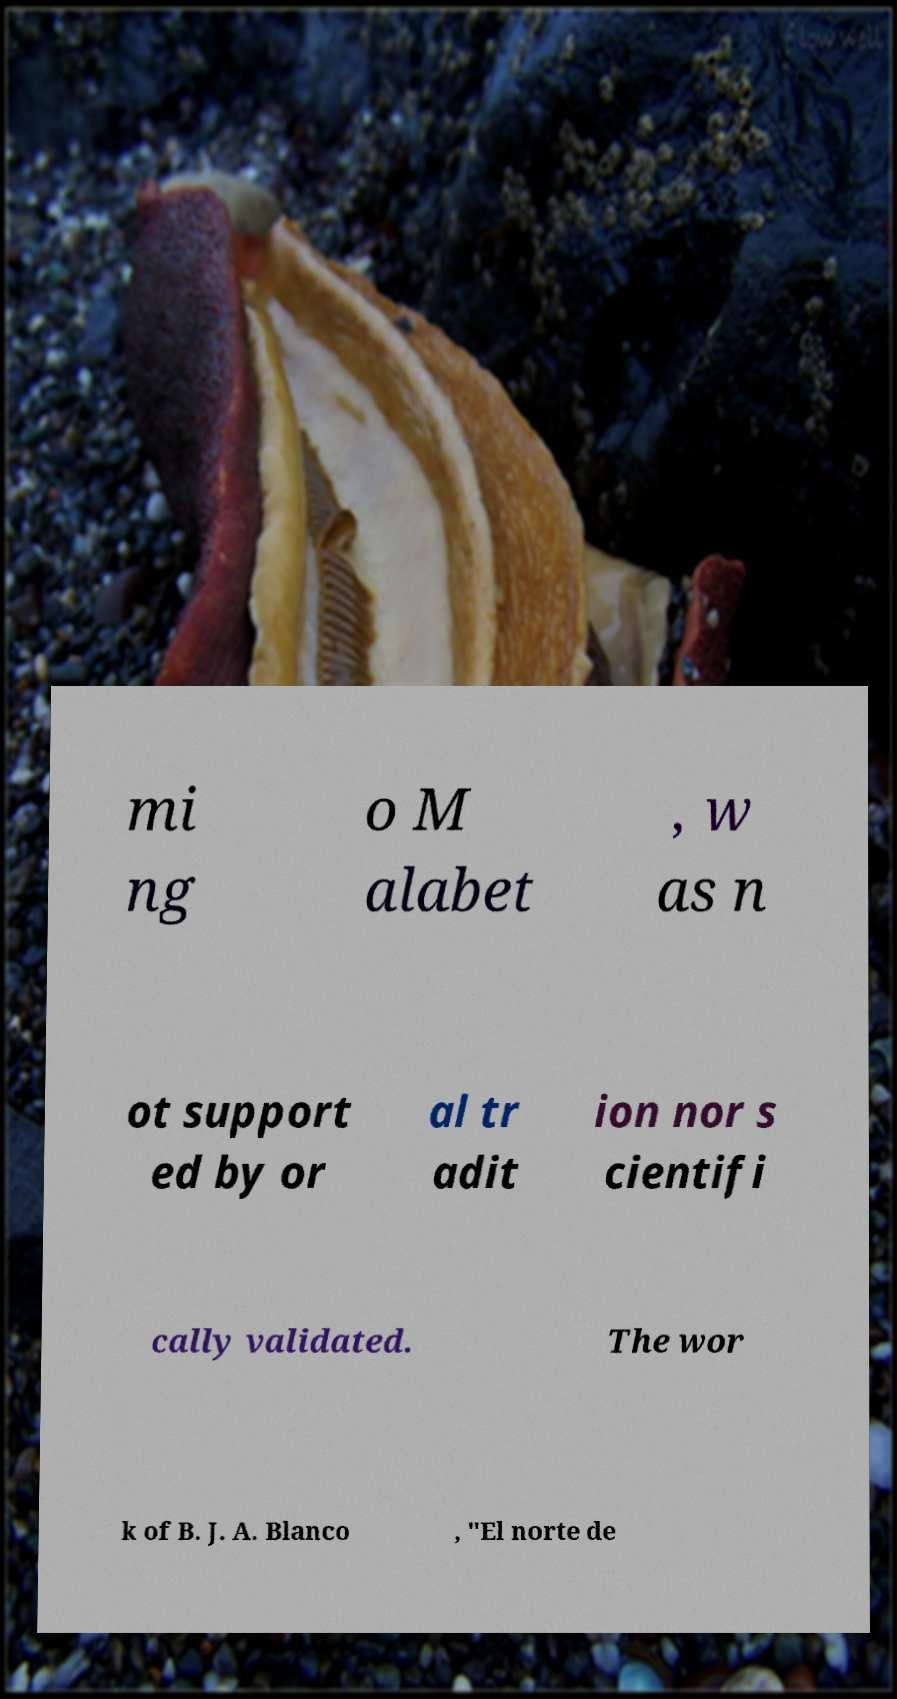For documentation purposes, I need the text within this image transcribed. Could you provide that? mi ng o M alabet , w as n ot support ed by or al tr adit ion nor s cientifi cally validated. The wor k of B. J. A. Blanco , "El norte de 